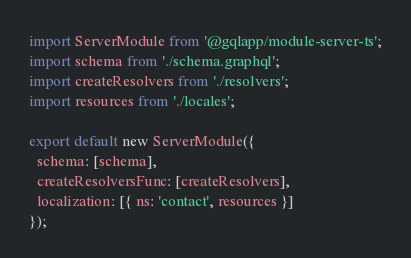<code> <loc_0><loc_0><loc_500><loc_500><_TypeScript_>import ServerModule from '@gqlapp/module-server-ts';
import schema from './schema.graphql';
import createResolvers from './resolvers';
import resources from './locales';

export default new ServerModule({
  schema: [schema],
  createResolversFunc: [createResolvers],
  localization: [{ ns: 'contact', resources }]
});
</code> 